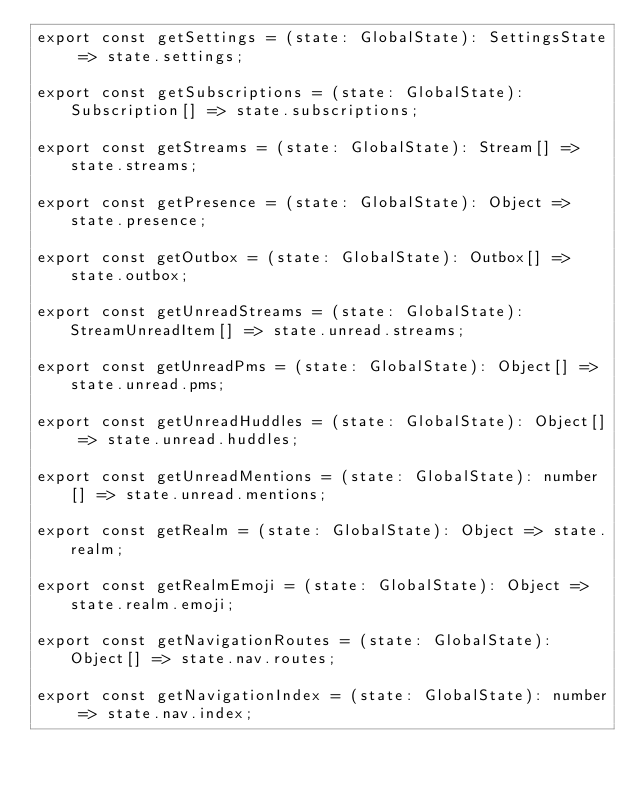Convert code to text. <code><loc_0><loc_0><loc_500><loc_500><_JavaScript_>export const getSettings = (state: GlobalState): SettingsState => state.settings;

export const getSubscriptions = (state: GlobalState): Subscription[] => state.subscriptions;

export const getStreams = (state: GlobalState): Stream[] => state.streams;

export const getPresence = (state: GlobalState): Object => state.presence;

export const getOutbox = (state: GlobalState): Outbox[] => state.outbox;

export const getUnreadStreams = (state: GlobalState): StreamUnreadItem[] => state.unread.streams;

export const getUnreadPms = (state: GlobalState): Object[] => state.unread.pms;

export const getUnreadHuddles = (state: GlobalState): Object[] => state.unread.huddles;

export const getUnreadMentions = (state: GlobalState): number[] => state.unread.mentions;

export const getRealm = (state: GlobalState): Object => state.realm;

export const getRealmEmoji = (state: GlobalState): Object => state.realm.emoji;

export const getNavigationRoutes = (state: GlobalState): Object[] => state.nav.routes;

export const getNavigationIndex = (state: GlobalState): number => state.nav.index;
</code> 